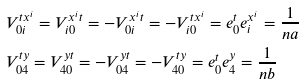Convert formula to latex. <formula><loc_0><loc_0><loc_500><loc_500>& V ^ { t x ^ { i } } _ { 0 i } = V ^ { x ^ { i } t } _ { i 0 } = - V ^ { x ^ { i } t } _ { 0 i } = - V ^ { t x ^ { i } } _ { i 0 } = e ^ { t } _ { 0 } e ^ { x ^ { i } } _ { i } = \frac { 1 } { n a } \\ & V ^ { t y } _ { 0 4 } = V ^ { y t } _ { 4 0 } = - V ^ { y t } _ { 0 4 } = - V ^ { t y } _ { 4 0 } = e ^ { t } _ { 0 } e ^ { y } _ { 4 } = \frac { 1 } { n b }</formula> 